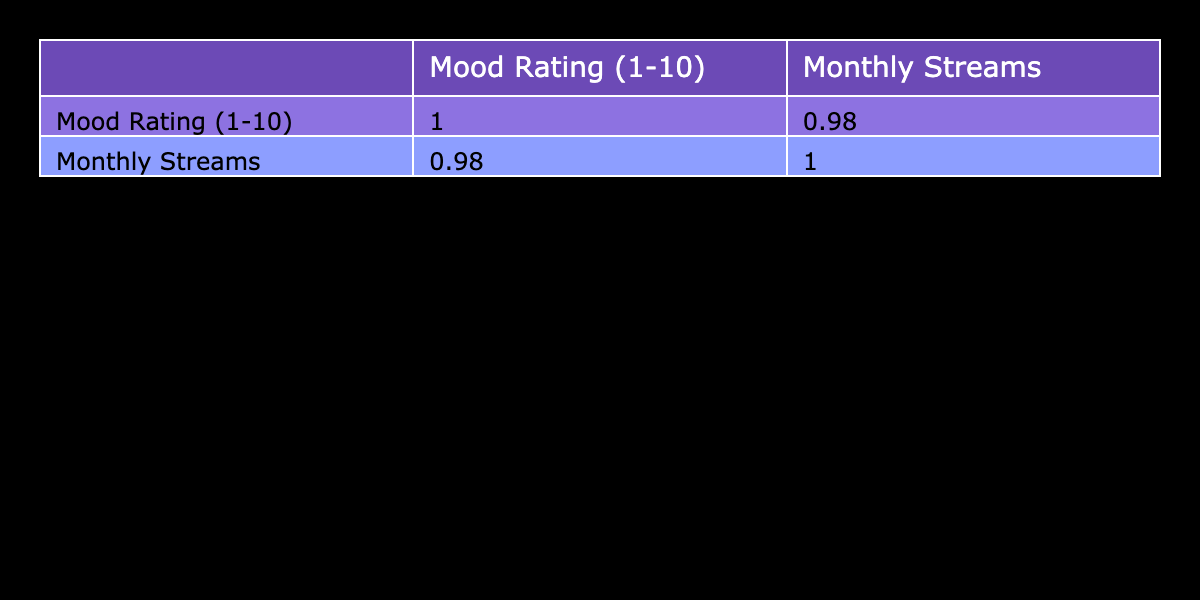What is the mood rating of the song "Guiltless"? By looking at the table under the 'Mood Rating (1-10)' column for the song title "Guiltless," we can see that it has a rating of 9.
Answer: 9 Which song has the highest monthly streams? Referring to the 'Monthly Streams' column, the song "Save Me" has the highest number, which is 2,000,000 monthly streams.
Answer: 2,000,000 Is there a song with a mood rating of 10? Checking the 'Mood Rating (1-10)' column, "Save Me" has a mood rating of 10, confirming the existence of such a song.
Answer: Yes What is the average mood rating of all the songs? The mood ratings are 8, 7, 9, 6, 7, 8, 10, 5, 8, and 6. Adding them gives a total of 78. Since there are 10 songs, the average is 78/10 = 7.8.
Answer: 7.8 How many songs have a mood rating of 7 or higher? From the list of mood ratings, we have the following ratings equal to or higher than 7: 8, 7, 9, 7, 8, 10, 8, which totals 7 songs.
Answer: 7 What is the correlation between mood ratings and monthly streams? By looking at the correlation matrix, we find the correlation coefficient between the mood ratings and monthly streams, which is approximately 0.89, indicating a strong positive correlation.
Answer: 0.89 Which song has the lowest mood rating and how many monthly streams does it have? "Just in Case" has the lowest mood rating of 5, and it has 500,000 monthly streams as shown in the respective columns.
Answer: 500,000 What is the difference between the highest and lowest monthly streams for the songs? The highest monthly streams is 2,000,000 for "Save Me," and the lowest is 500,000 for "Just in Case." The difference is 2,000,000 - 500,000 = 1,500,000.
Answer: 1,500,000 How many songs have a mood rating of 6? Looking at the 'Mood Rating (1-10)' column, only "Party Tattoos" and "Life Gone" have a mood rating of 6, making it a total of 2 songs.
Answer: 2 